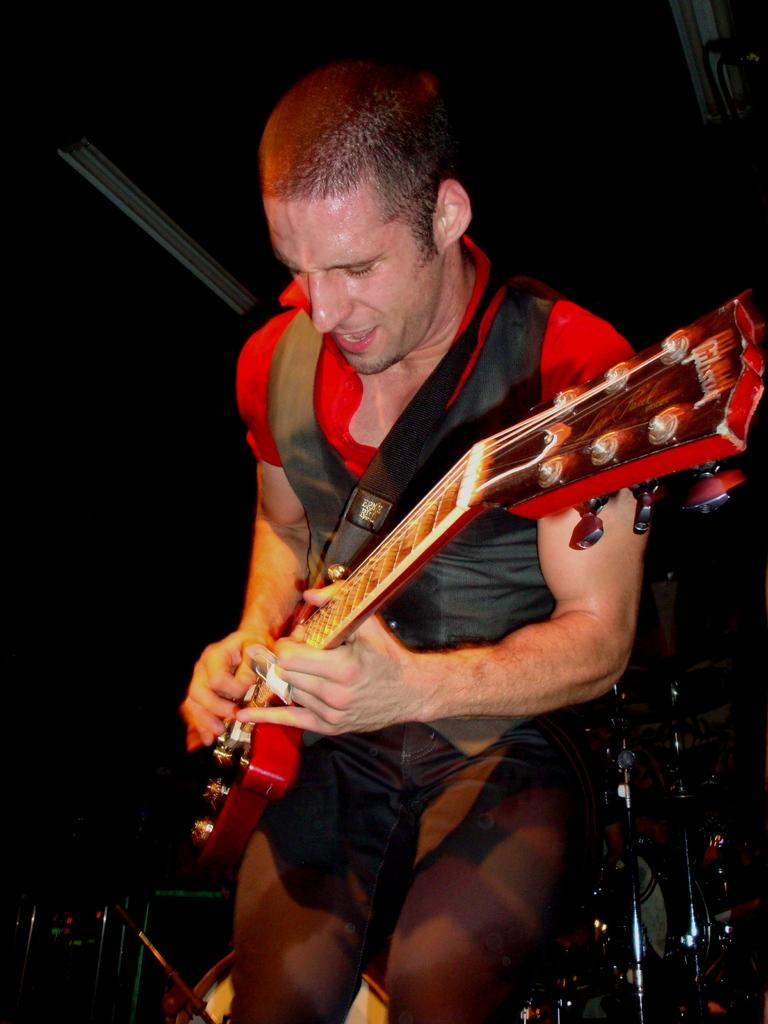What is the main subject of the image? There is a person in the image. What is the person doing in the image? The person is playing a guitar. Can you describe the background of the image? The background of the image is dark. What type of oil can be seen dripping from the person's fingers in the image? There is no oil present in the image, and the person's fingers are not shown to be dripping with any substance. 